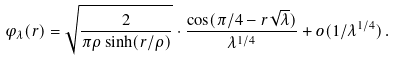<formula> <loc_0><loc_0><loc_500><loc_500>\varphi _ { \lambda } ( r ) = \sqrt { \frac { 2 } { \pi \rho \sinh ( r / \rho ) } } \cdot \frac { \cos ( \pi / 4 - r \sqrt { \lambda } ) } { \lambda ^ { 1 / 4 } } + o ( 1 / \lambda ^ { 1 / 4 } ) \, .</formula> 